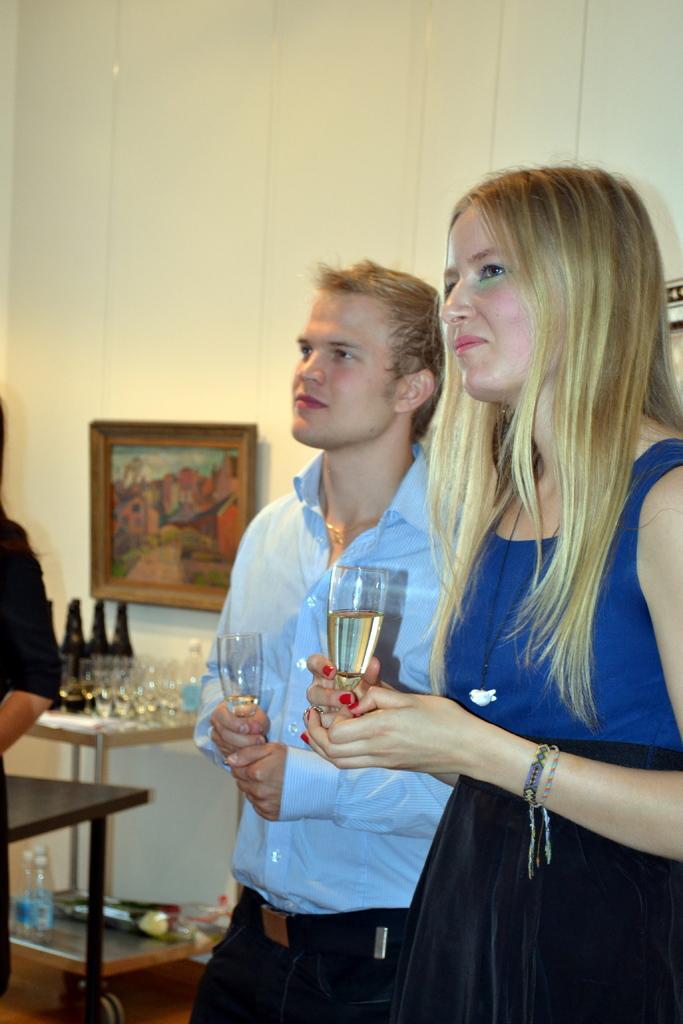Could you give a brief overview of what you see in this image? In the foreground of the image there are two people wearing glasses. In the background of the image there is wall. There is a photo frame. There is a table with bottles and glasses. To the left side of the image there is a person. 